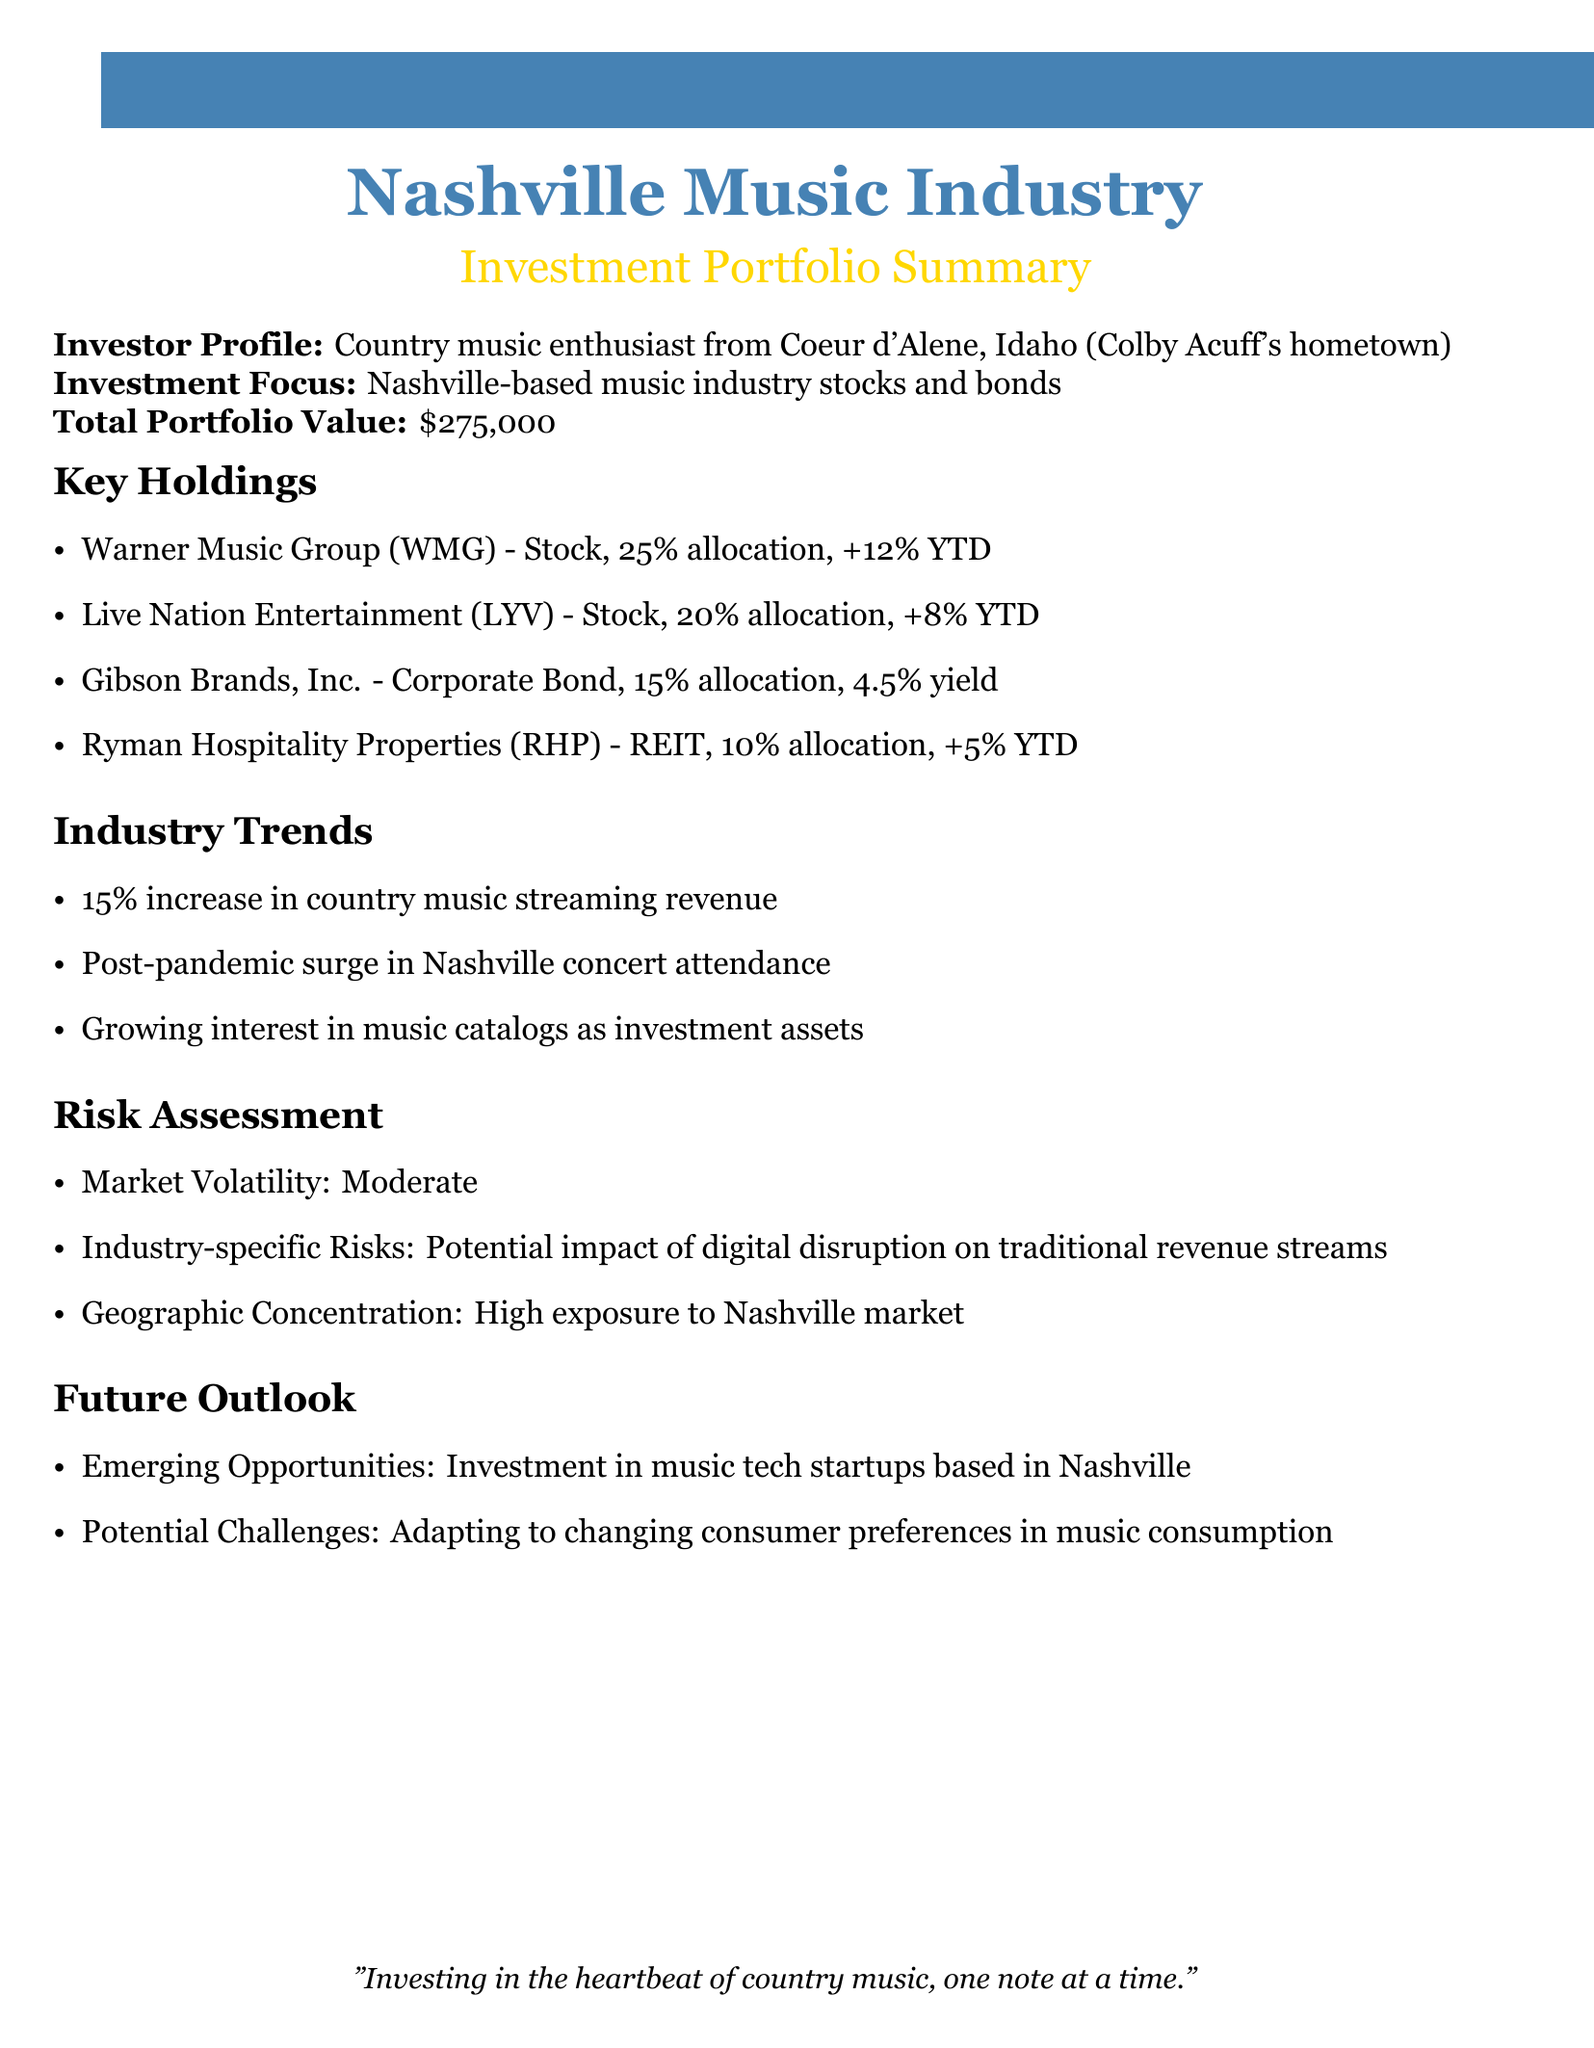What is the total portfolio value? The total portfolio value is stated in the document as $275,000.
Answer: $275,000 What is the allocation percentage for Warner Music Group? The document specifies that Warner Music Group has a 25% allocation in the portfolio.
Answer: 25% What is the performance of Live Nation Entertainment year-to-date? The performance of Live Nation Entertainment year-to-date, as presented in the document, is +8%.
Answer: +8% What type of asset is Gibson Brands, Inc.? The document identifies Gibson Brands, Inc. as a corporate bond.
Answer: Corporate Bond What is the yield of the corporate bond in the portfolio? The yield for Gibson Brands, Inc., which is a corporate bond, is indicated to be 4.5%.
Answer: 4.5% What is a potential future challenge mentioned in the document? The document states that a potential future challenge is adapting to changing consumer preferences in music consumption.
Answer: Adapting to changing consumer preferences What trend in country music streaming revenue is mentioned? The document notes a 15% increase in country music streaming revenue.
Answer: 15% increase What is the geographic concentration risk noted in the report? The report indicates that there is a high exposure to the Nashville market as a geographic concentration risk.
Answer: High exposure to Nashville market What emerging opportunity is highlighted for the future? The emerging opportunity mentioned in the document is investment in music tech startups based in Nashville.
Answer: Investment in music tech startups 